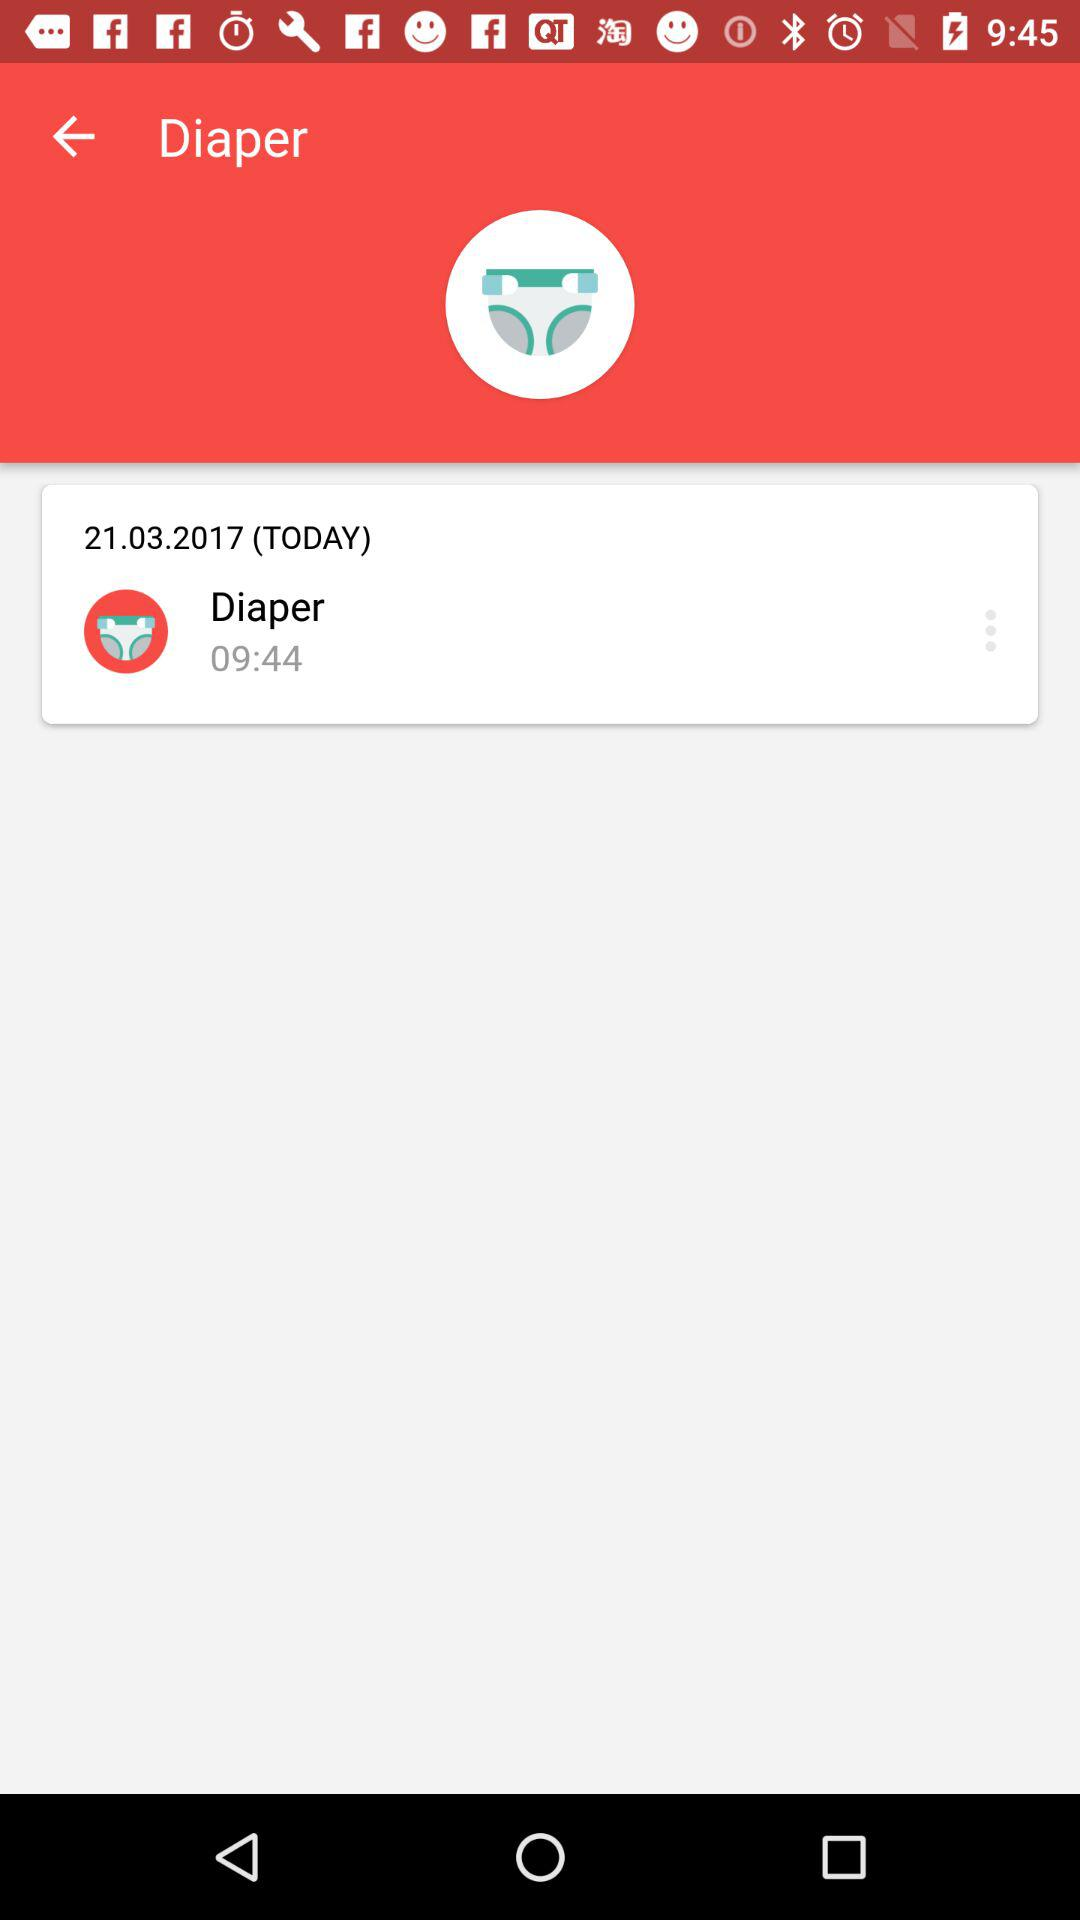What is the application name? The application name is "Diaper". 